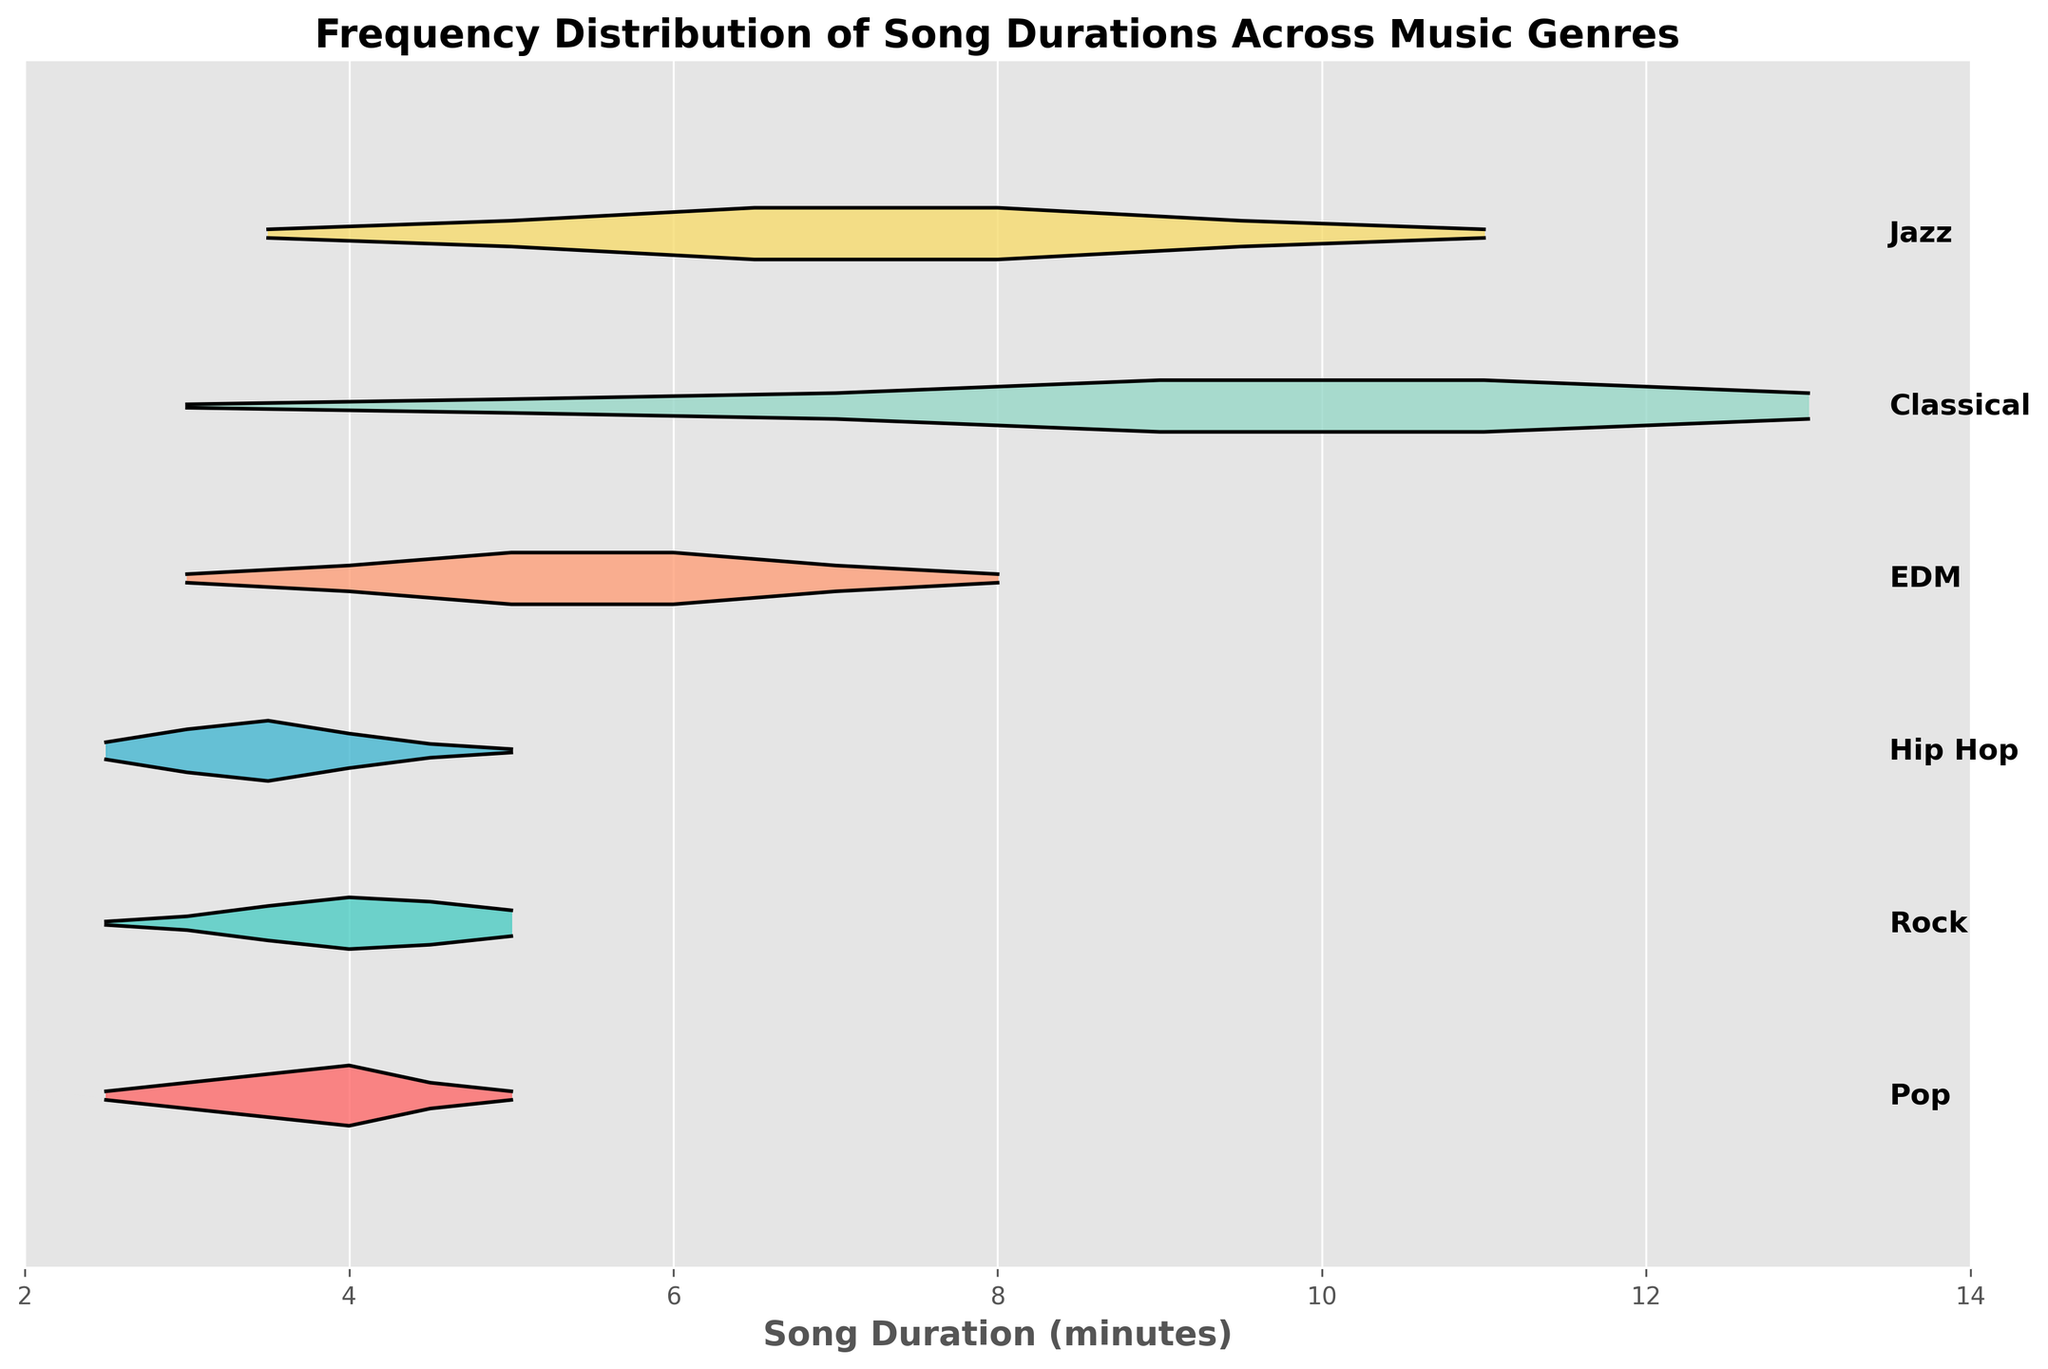Which genre has the longest peak duration value? The plot's peaks for each genre indicate the most frequent durations. For Classical, the peak extends up to 13 minutes, which is the highest peak value compared to others.
Answer: Classical Which genre has the shortest average duration? Considering the distribution and density of the peaks, Hip Hop's distribution shows clustered peaks around 2.5 to 3.5 minutes, suggesting a shorter average duration.
Answer: Hip Hop How does the density of durations in Pop compare to that in Rock? Pop has its highest density at the 4-minute mark, while Rock has a comparable density, but with a less pronounced peak, distributed more around 3 to 4.5 minutes.
Answer: Pop has a higher peak density around 4 minutes compared to Rock What is the range of song durations for Jazz? Jazz songs' durations range from 3.5 minutes to 11 minutes as indicated by its start and end points on the horizontal duration axis.
Answer: 3.5 to 11 minutes Which genre has the most even distribution across its duration range? EDM shows a relatively uniform density across its duration range (3 to 8 minutes), with two peaks of equal height at 5 and 6 minutes, suggesting an even distribution.
Answer: EDM Which genre peaks at around 9 minutes in duration? Classical and Jazz both show peaks at 9 minutes, but the density is higher for Classical at this point.
Answer: Classical Is there any genre where the song durations exceed 10 minutes? If so, which one(s)? Both Classical and Jazz genres have song durations exceeding 10 minutes, with Classical going up to 13 minutes and Jazz up to 11 minutes.
Answer: Classical and Jazz Does any genre have a significant peak or concentration of songs at exactly 4 minutes? The Pop genre has a significant peak around the 4-minute mark, indicating a high concentration of songs of this duration.
Answer: Pop 